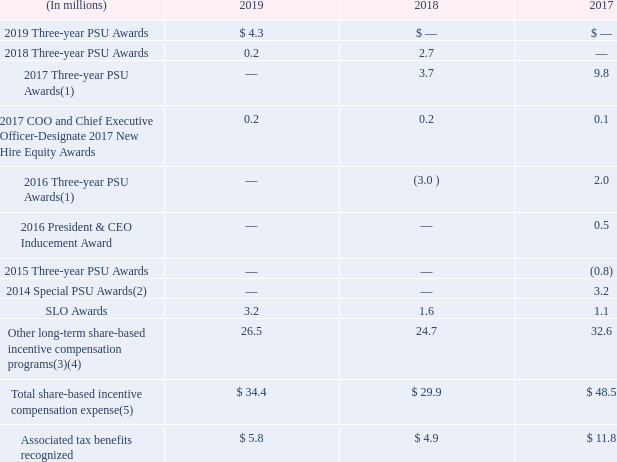The following table years ended December 31, 2019, 2018 and 2017 related to the Company’s PSU awards, SLO awards and restricted stock awards.
(1) On May 18, 2017, The Organization and Compensation Committee of our Board of Directors (“O&C Committee”) approved a change in the vesting policy regarding the existing 2017 Three-year PSU Awards and 2016 Three-year PSU Awards for Ilham Kadri. The approved change resulted in a pro-rata share of vesting calculated on the close date of the sale of Diversey. Dr. Kadri’s awards were still subject to the performance metrics stipulated in the plan documents, and will be paid out in accordance with the original planned timing.
(2) The amount does not include expense related to the 2014 Special PSU awards that were settled in cash of $1.0 million in the year ended December 31, 2017.
(3) The amount includes the expenses associated with the restricted stock awards consisting of restricted stock shares, restricted stock units and cash-settled restricted stock unit awards.
(4) On August 4, 2017, the Equity Award Committee approved a change in the vesting condition regarding the existing long-term share-based compensation programs transferring to Diversey as part of the sale of Diversey. The approved change resulted in a pro-rata share of vesting calculated on the close date of the sale of Diversey. In December 2018, the Equity Award Committee approved a change in the vesting condition for certain individuals who would be leaving the Company under a phase of our Reinvent SEE Restructuring program. For both modifications, we recorded the cumulative expense of the higher fair value of the impacted awards at modification approval.
(5) The amounts do not include the expense related to our U.S. profit sharing contributions made in the form of our common stock as these contributions are not considered share-based incentive compensation.
What does the table show? Company’s psu awards, slo awards and restricted stock awards. What was approved on May 18, 2017 by The Organization and Compensation Committee of our Board of Directors (“O&C Committee”)? Change in the vesting policy regarding the existing 2017 three-year psu awards and 2016 three-year psu awards for ilham kadri. the approved change resulted in a pro-rata share of vesting calculated on the close date of the sale of diversey. What years are included in the table? 2019, 2018, 2017. What is the sum of Three-year PSU awards for all years as of 2019?
Answer scale should be: million. 4.3+0.2
Answer: 4.5. What is the average annual Total share-based incentive compensation expense?
Answer scale should be: million. (34.4+29.9+48.5)/3
Answer: 37.6. For 2017, what is the sum of all the Three-year PSU Awards expressed as a percentage of Total share-based incentive compensation expense?
Answer scale should be: percent. (9.8+2.0-0.8)/48.5
Answer: 22.68. 